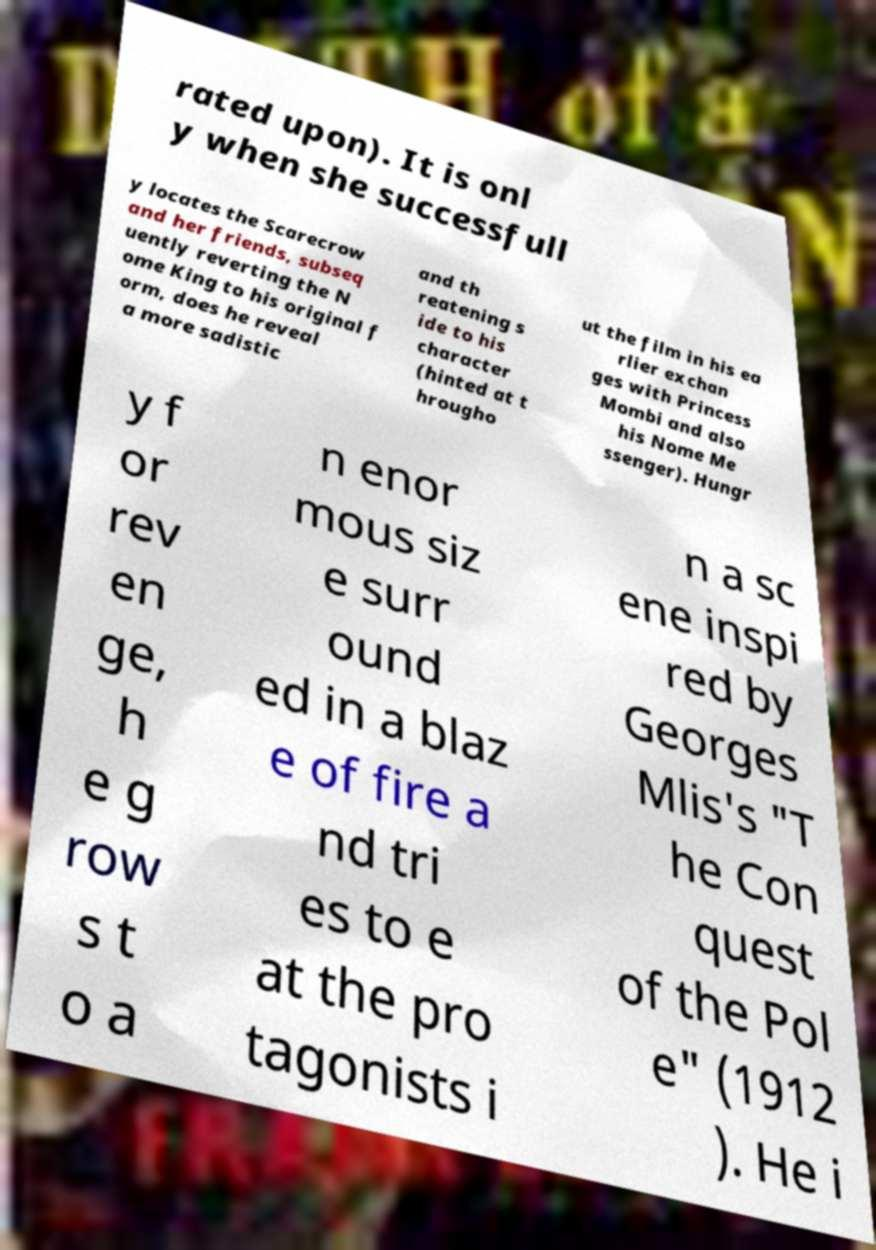Please read and relay the text visible in this image. What does it say? rated upon). It is onl y when she successfull y locates the Scarecrow and her friends, subseq uently reverting the N ome King to his original f orm, does he reveal a more sadistic and th reatening s ide to his character (hinted at t hrougho ut the film in his ea rlier exchan ges with Princess Mombi and also his Nome Me ssenger). Hungr y f or rev en ge, h e g row s t o a n enor mous siz e surr ound ed in a blaz e of fire a nd tri es to e at the pro tagonists i n a sc ene inspi red by Georges Mlis's "T he Con quest of the Pol e" (1912 ). He i 